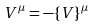Convert formula to latex. <formula><loc_0><loc_0><loc_500><loc_500>V ^ { \mu } = - \{ V \} ^ { \mu }</formula> 